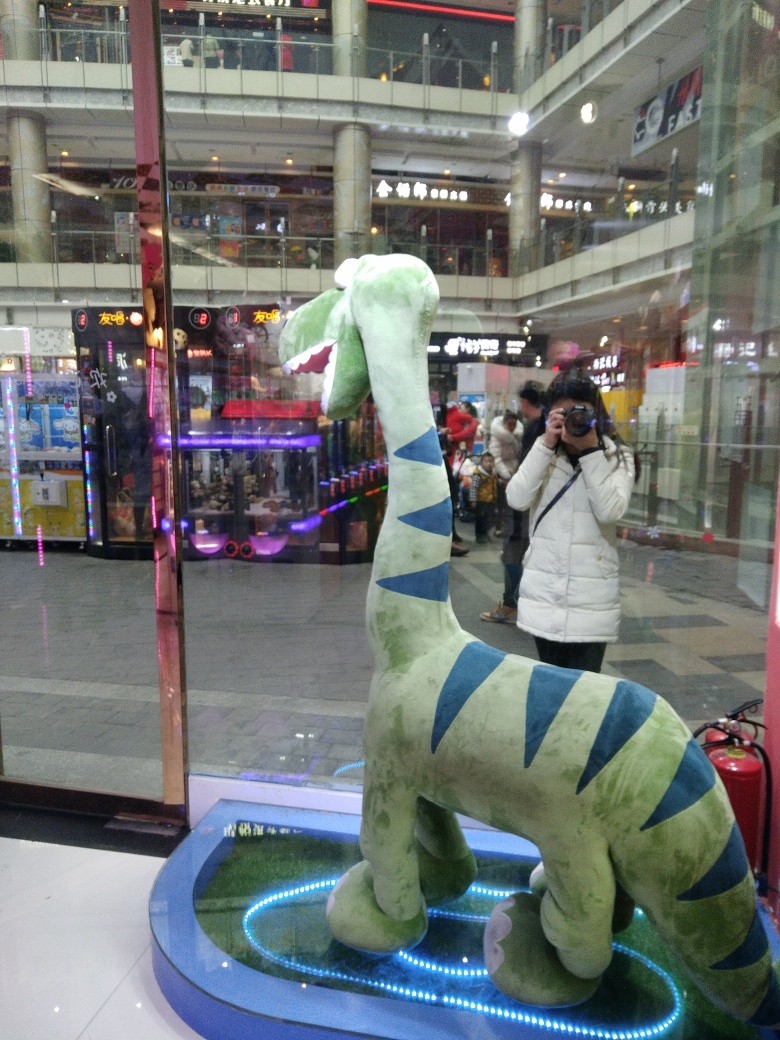How would you describe the composition of the image?
A. mediocre, with an unclear subject
B. bad, with an obscure subject
C. good, with a prominent subject
D. excellent, with an insignificant subject
Answer with the option's letter from the given choices directly.
 C. 